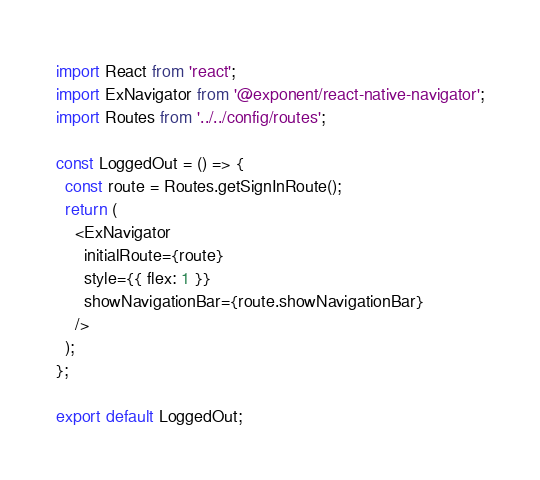<code> <loc_0><loc_0><loc_500><loc_500><_JavaScript_>import React from 'react';
import ExNavigator from '@exponent/react-native-navigator';
import Routes from '../../config/routes';

const LoggedOut = () => {
  const route = Routes.getSignInRoute();
  return (
    <ExNavigator
      initialRoute={route}
      style={{ flex: 1 }}
      showNavigationBar={route.showNavigationBar}
    />
  );
};

export default LoggedOut;
</code> 